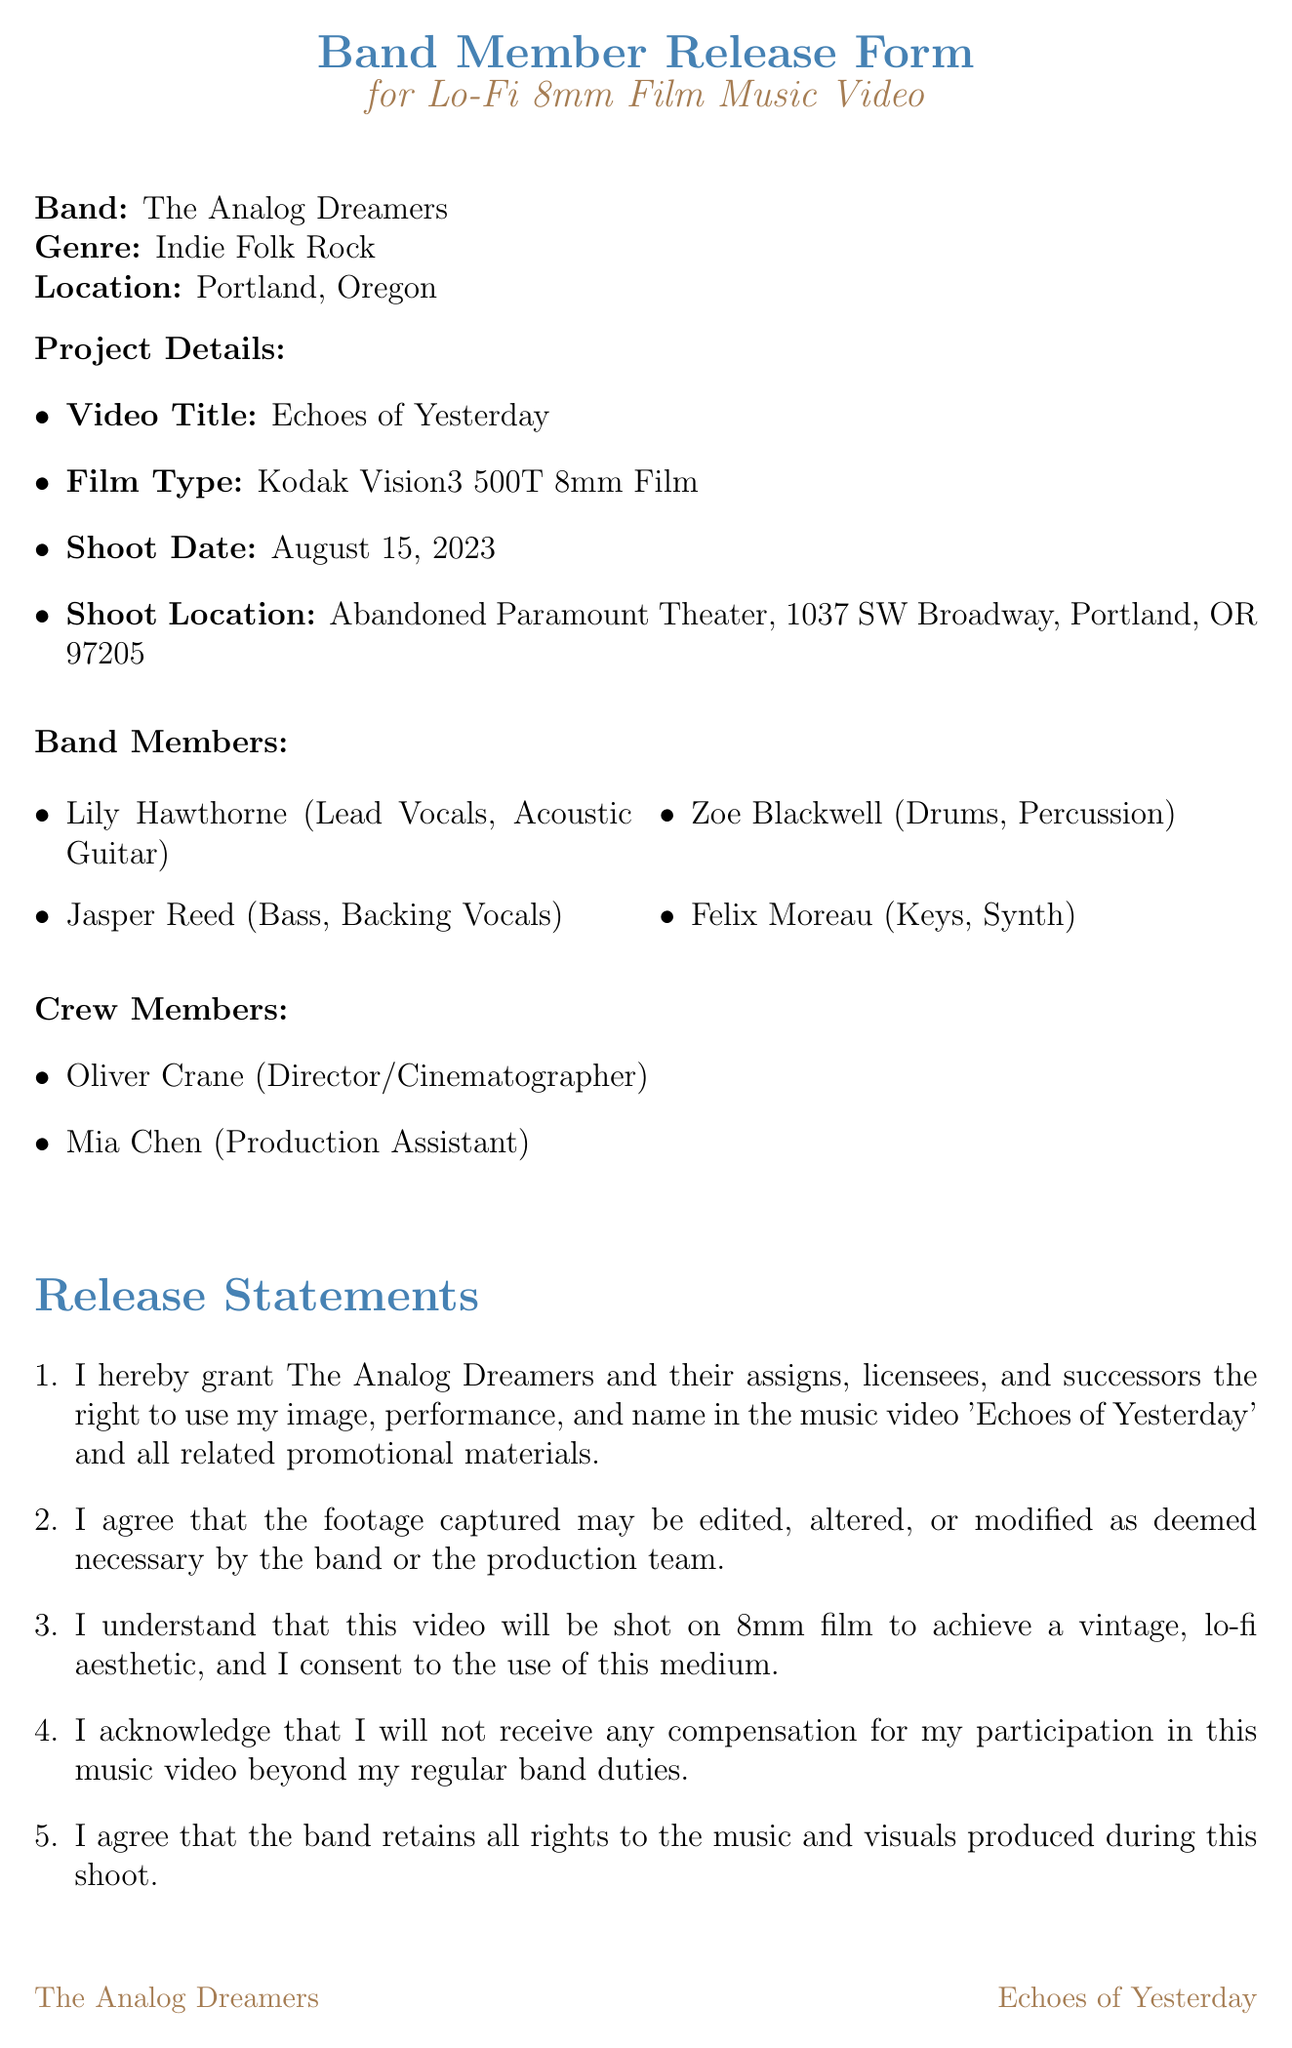What is the name of the band? The name of the band is mentioned at the beginning of the document.
Answer: The Analog Dreamers What is the genre of the band? The genre is stated right after the band name in the document.
Answer: Indie Folk Rock What type of film is being used for the shoot? The type of film is specified under project details in the document.
Answer: Kodak Vision3 500T 8mm Film What is the shoot location? The location is provided in the project details section.
Answer: Abandoned Paramount Theater, 1037 SW Broadway, Portland, OR 97205 What is the date of the shoot? The date can be found in the project details section of the document.
Answer: August 15, 2023 Who is the director of the music video? The director's name is listed under crew members in the document.
Answer: Oliver Crane What time should band members arrive at the shoot location? The arrival time is specified in the additional clauses section.
Answer: 9:00 AM Do band members receive compensation for their participation? This information is included in the release statements section.
Answer: No What must each band member bring to the shoot? This requirement is detailed in the additional clauses section.
Answer: Their own instruments and specific vintage clothing items What is the legal jurisdiction stated in the document? The jurisdiction is mentioned in the legal disclaimer at the end of the document.
Answer: State of Oregon 